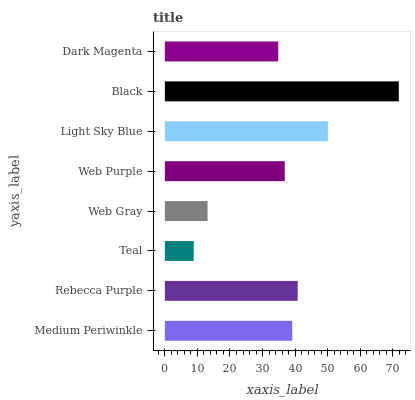Is Teal the minimum?
Answer yes or no. Yes. Is Black the maximum?
Answer yes or no. Yes. Is Rebecca Purple the minimum?
Answer yes or no. No. Is Rebecca Purple the maximum?
Answer yes or no. No. Is Rebecca Purple greater than Medium Periwinkle?
Answer yes or no. Yes. Is Medium Periwinkle less than Rebecca Purple?
Answer yes or no. Yes. Is Medium Periwinkle greater than Rebecca Purple?
Answer yes or no. No. Is Rebecca Purple less than Medium Periwinkle?
Answer yes or no. No. Is Medium Periwinkle the high median?
Answer yes or no. Yes. Is Web Purple the low median?
Answer yes or no. Yes. Is Light Sky Blue the high median?
Answer yes or no. No. Is Medium Periwinkle the low median?
Answer yes or no. No. 